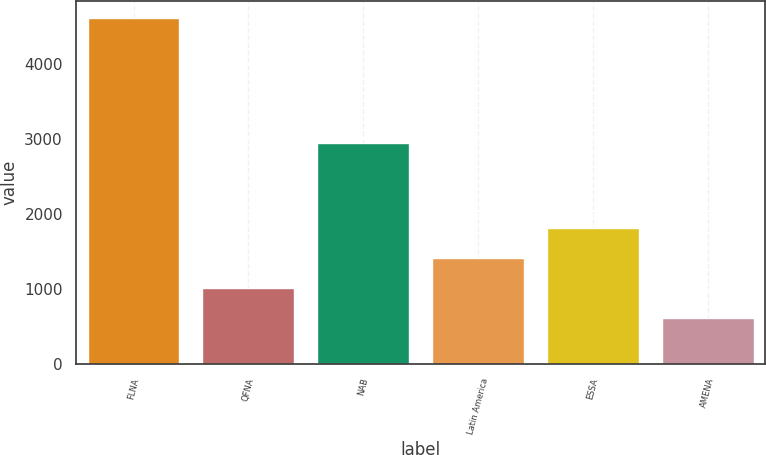<chart> <loc_0><loc_0><loc_500><loc_500><bar_chart><fcel>FLNA<fcel>QFNA<fcel>NAB<fcel>Latin America<fcel>ESSA<fcel>AMENA<nl><fcel>4612<fcel>1018.3<fcel>2947<fcel>1417.6<fcel>1816.9<fcel>619<nl></chart> 